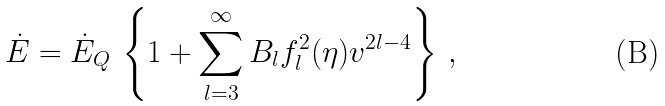<formula> <loc_0><loc_0><loc_500><loc_500>\dot { E } = \dot { E } _ { Q } \, \left \{ 1 + \sum _ { l = 3 } ^ { \infty } B _ { l } f ^ { 2 } _ { l } ( \eta ) v ^ { 2 l - 4 } \right \} \, ,</formula> 